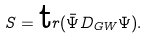<formula> <loc_0><loc_0><loc_500><loc_500>S = { \text  tr}(\bar{\Psi} D_{GW} \Psi).</formula> 